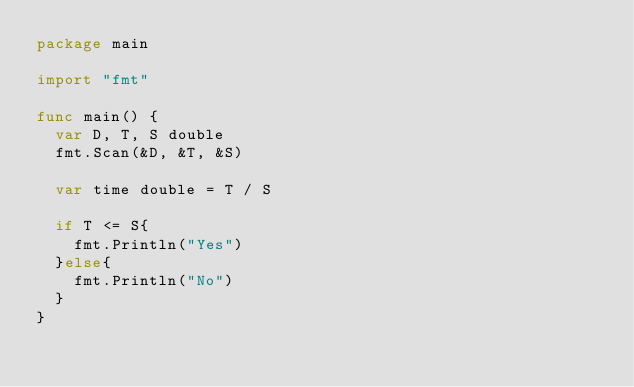Convert code to text. <code><loc_0><loc_0><loc_500><loc_500><_Go_>package main

import "fmt"

func main() {
	var D, T, S double
	fmt.Scan(&D, &T, &S)
  
  var time double = T / S
  
  if T <= S{
    fmt.Println("Yes")
  }else{
    fmt.Println("No")
  }
}</code> 